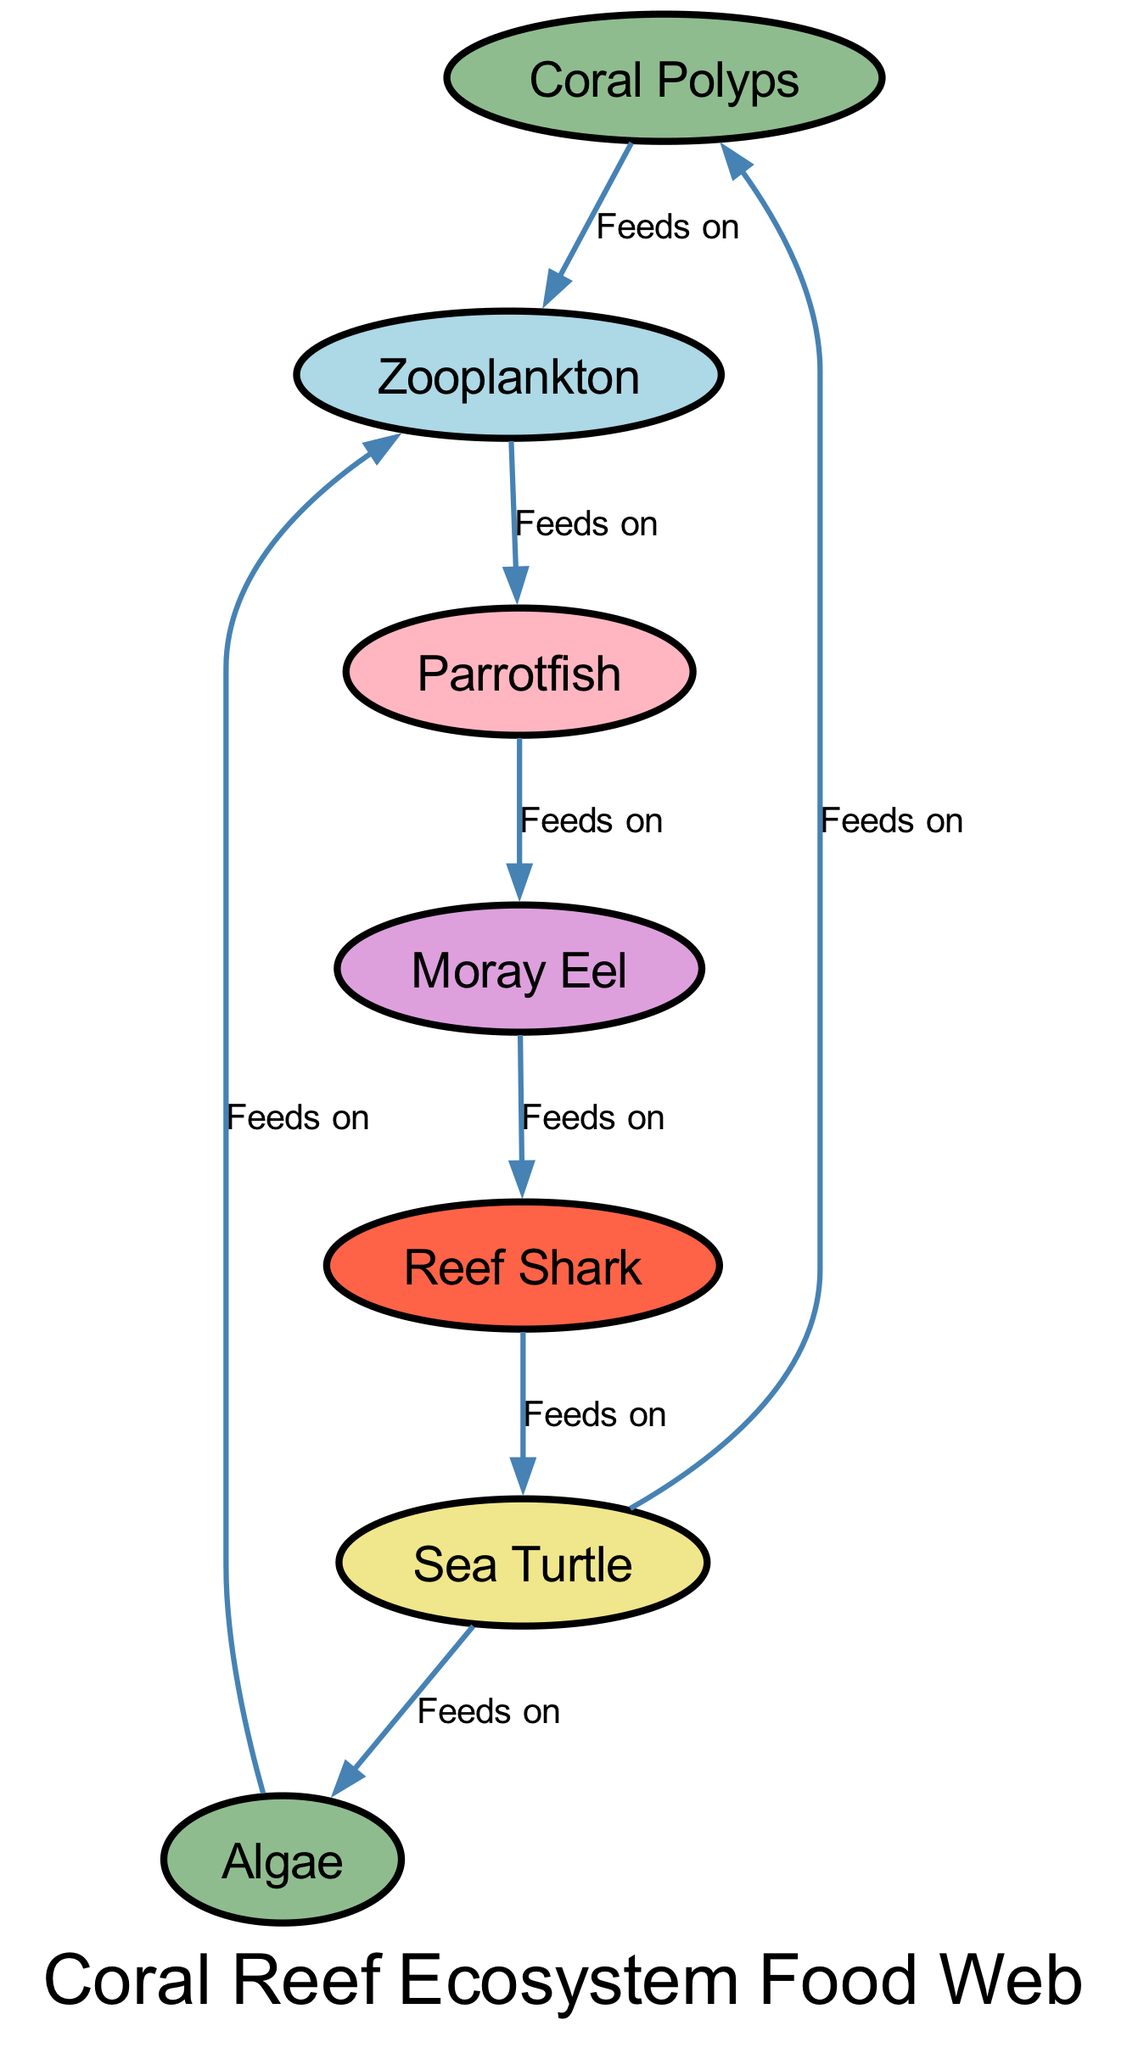What are the primary producers in this food web? The primary producers are organisms that create energy from sunlight or chemicals. In the diagram, coral polyps and algae are listed as primary producers.
Answer: Coral Polyps, Algae How many apex predators are shown in the diagram? An apex predator is the top of the food chain and has no natural predators. In the diagram, there is one apex predator, which is the reef shark.
Answer: 1 Which species feeds on both coral polyps and algae? To find the species that feeds on both, we look for a node that has edges going from both the coral polyps and algae nodes. The sea turtle is connected to both the coral polyps and algae in the diagram.
Answer: Sea Turtle What type of organism is the moray eel? To answer this, we identify the node corresponding to the moray eel in the diagram. It is labeled as a tertiary consumer in the diagram.
Answer: Tertiary Consumer Which species is at the top of the food web? The species at the top of the food web is the apex predator, which in this diagram is the reef shark. We determine this by looking at the relationships that identify it as having no predators in this system.
Answer: Reef Shark What is the total number of nodes in the food web? To determine the total number of nodes, we count all the unique species and producers listed in the diagram. There are seven different nodes present.
Answer: 7 Which consumer is directly fed on by the parrotfish? The parrotfish, being a secondary consumer, has a direct feeding relationship leading to the moray eel, which is identified as the next node in the feeding hierarchy.
Answer: Moray Eel How many edges are there in total? By counting the connections (edges) shown in the diagram, we add each relationship that indicates one species feeding on another. There are eight edges connecting the nodes.
Answer: 8 What type of consumer is the parrotfish? Looking at the label and classification for the parrotfish in the diagram, we find it classified as a secondary consumer.
Answer: Secondary Consumer 